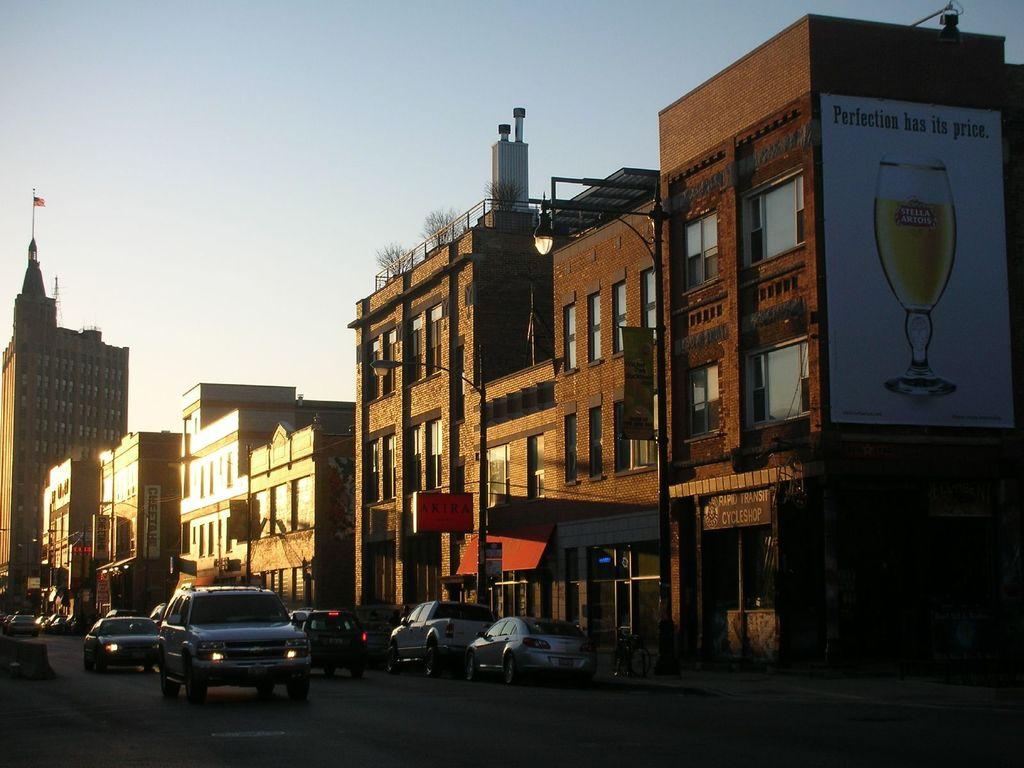What type of structures can be seen in the image? There are buildings in the image. What else can be seen on the road in the image? Vehicles are present on the road in the image. What is used to illuminate the road at night in the image? Street lights are visible in the image. What type of natural elements are present in the image? Plants are present in the image. What is attached to one of the buildings in the image? There is a flag on a building in the image. What are the boards attached to in the image? The boards are attached to the buildings in the image. What can be seen in the background of the image? The sky is visible in the background of the image. What type of scarf is draped over the flagpole in the image? There is no scarf present in the image; only a flag is attached to the building. What type of soda is being advertised on the boards attached to the buildings in the image? There is no soda advertisement on the boards in the image; the boards contain other information or advertisements. 